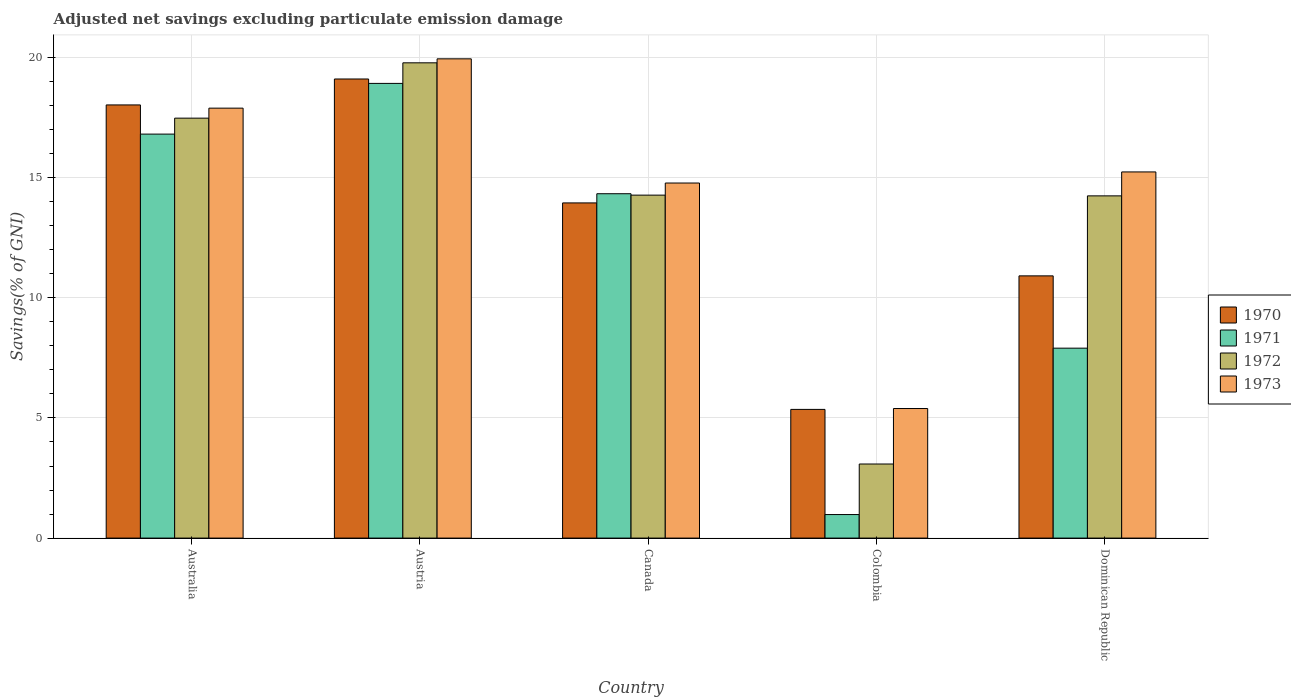Are the number of bars on each tick of the X-axis equal?
Provide a succinct answer. Yes. How many bars are there on the 1st tick from the left?
Make the answer very short. 4. How many bars are there on the 4th tick from the right?
Offer a terse response. 4. What is the label of the 1st group of bars from the left?
Keep it short and to the point. Australia. What is the adjusted net savings in 1973 in Colombia?
Your answer should be very brief. 5.39. Across all countries, what is the maximum adjusted net savings in 1970?
Make the answer very short. 19.11. Across all countries, what is the minimum adjusted net savings in 1970?
Provide a short and direct response. 5.36. In which country was the adjusted net savings in 1972 minimum?
Provide a short and direct response. Colombia. What is the total adjusted net savings in 1973 in the graph?
Give a very brief answer. 73.24. What is the difference between the adjusted net savings in 1973 in Austria and that in Colombia?
Provide a succinct answer. 14.55. What is the difference between the adjusted net savings in 1970 in Dominican Republic and the adjusted net savings in 1971 in Canada?
Ensure brevity in your answer.  -3.42. What is the average adjusted net savings in 1970 per country?
Ensure brevity in your answer.  13.47. What is the difference between the adjusted net savings of/in 1970 and adjusted net savings of/in 1973 in Dominican Republic?
Your answer should be very brief. -4.33. In how many countries, is the adjusted net savings in 1972 greater than 11 %?
Provide a short and direct response. 4. What is the ratio of the adjusted net savings in 1970 in Austria to that in Colombia?
Provide a short and direct response. 3.57. What is the difference between the highest and the second highest adjusted net savings in 1972?
Give a very brief answer. -2.3. What is the difference between the highest and the lowest adjusted net savings in 1972?
Offer a very short reply. 16.7. Is the sum of the adjusted net savings in 1972 in Canada and Colombia greater than the maximum adjusted net savings in 1970 across all countries?
Provide a succinct answer. No. Is it the case that in every country, the sum of the adjusted net savings in 1970 and adjusted net savings in 1973 is greater than the sum of adjusted net savings in 1972 and adjusted net savings in 1971?
Ensure brevity in your answer.  No. How many bars are there?
Provide a succinct answer. 20. How many countries are there in the graph?
Provide a short and direct response. 5. Are the values on the major ticks of Y-axis written in scientific E-notation?
Provide a short and direct response. No. Does the graph contain any zero values?
Give a very brief answer. No. Does the graph contain grids?
Your answer should be compact. Yes. Where does the legend appear in the graph?
Your response must be concise. Center right. What is the title of the graph?
Offer a terse response. Adjusted net savings excluding particulate emission damage. Does "1964" appear as one of the legend labels in the graph?
Keep it short and to the point. No. What is the label or title of the X-axis?
Your answer should be compact. Country. What is the label or title of the Y-axis?
Offer a terse response. Savings(% of GNI). What is the Savings(% of GNI) in 1970 in Australia?
Offer a terse response. 18.03. What is the Savings(% of GNI) in 1971 in Australia?
Make the answer very short. 16.81. What is the Savings(% of GNI) in 1972 in Australia?
Provide a succinct answer. 17.48. What is the Savings(% of GNI) in 1973 in Australia?
Your response must be concise. 17.89. What is the Savings(% of GNI) in 1970 in Austria?
Make the answer very short. 19.11. What is the Savings(% of GNI) of 1971 in Austria?
Keep it short and to the point. 18.92. What is the Savings(% of GNI) in 1972 in Austria?
Ensure brevity in your answer.  19.78. What is the Savings(% of GNI) in 1973 in Austria?
Provide a succinct answer. 19.94. What is the Savings(% of GNI) in 1970 in Canada?
Give a very brief answer. 13.95. What is the Savings(% of GNI) of 1971 in Canada?
Your response must be concise. 14.33. What is the Savings(% of GNI) in 1972 in Canada?
Offer a terse response. 14.27. What is the Savings(% of GNI) in 1973 in Canada?
Offer a terse response. 14.78. What is the Savings(% of GNI) in 1970 in Colombia?
Your response must be concise. 5.36. What is the Savings(% of GNI) of 1971 in Colombia?
Your answer should be very brief. 0.98. What is the Savings(% of GNI) in 1972 in Colombia?
Provide a short and direct response. 3.08. What is the Savings(% of GNI) of 1973 in Colombia?
Keep it short and to the point. 5.39. What is the Savings(% of GNI) in 1970 in Dominican Republic?
Your answer should be very brief. 10.91. What is the Savings(% of GNI) in 1971 in Dominican Republic?
Ensure brevity in your answer.  7.9. What is the Savings(% of GNI) of 1972 in Dominican Republic?
Your answer should be compact. 14.24. What is the Savings(% of GNI) of 1973 in Dominican Republic?
Make the answer very short. 15.24. Across all countries, what is the maximum Savings(% of GNI) in 1970?
Keep it short and to the point. 19.11. Across all countries, what is the maximum Savings(% of GNI) in 1971?
Your response must be concise. 18.92. Across all countries, what is the maximum Savings(% of GNI) in 1972?
Give a very brief answer. 19.78. Across all countries, what is the maximum Savings(% of GNI) in 1973?
Provide a short and direct response. 19.94. Across all countries, what is the minimum Savings(% of GNI) of 1970?
Offer a terse response. 5.36. Across all countries, what is the minimum Savings(% of GNI) in 1971?
Offer a very short reply. 0.98. Across all countries, what is the minimum Savings(% of GNI) in 1972?
Your answer should be compact. 3.08. Across all countries, what is the minimum Savings(% of GNI) in 1973?
Provide a short and direct response. 5.39. What is the total Savings(% of GNI) in 1970 in the graph?
Keep it short and to the point. 67.35. What is the total Savings(% of GNI) of 1971 in the graph?
Give a very brief answer. 58.95. What is the total Savings(% of GNI) of 1972 in the graph?
Give a very brief answer. 68.85. What is the total Savings(% of GNI) in 1973 in the graph?
Your response must be concise. 73.24. What is the difference between the Savings(% of GNI) in 1970 in Australia and that in Austria?
Make the answer very short. -1.08. What is the difference between the Savings(% of GNI) in 1971 in Australia and that in Austria?
Make the answer very short. -2.11. What is the difference between the Savings(% of GNI) in 1972 in Australia and that in Austria?
Ensure brevity in your answer.  -2.3. What is the difference between the Savings(% of GNI) in 1973 in Australia and that in Austria?
Offer a very short reply. -2.05. What is the difference between the Savings(% of GNI) in 1970 in Australia and that in Canada?
Offer a very short reply. 4.08. What is the difference between the Savings(% of GNI) in 1971 in Australia and that in Canada?
Your response must be concise. 2.48. What is the difference between the Savings(% of GNI) of 1972 in Australia and that in Canada?
Give a very brief answer. 3.2. What is the difference between the Savings(% of GNI) of 1973 in Australia and that in Canada?
Offer a terse response. 3.12. What is the difference between the Savings(% of GNI) in 1970 in Australia and that in Colombia?
Your answer should be very brief. 12.67. What is the difference between the Savings(% of GNI) of 1971 in Australia and that in Colombia?
Provide a short and direct response. 15.83. What is the difference between the Savings(% of GNI) of 1972 in Australia and that in Colombia?
Offer a very short reply. 14.39. What is the difference between the Savings(% of GNI) in 1973 in Australia and that in Colombia?
Offer a terse response. 12.5. What is the difference between the Savings(% of GNI) of 1970 in Australia and that in Dominican Republic?
Give a very brief answer. 7.11. What is the difference between the Savings(% of GNI) in 1971 in Australia and that in Dominican Republic?
Keep it short and to the point. 8.91. What is the difference between the Savings(% of GNI) in 1972 in Australia and that in Dominican Republic?
Offer a terse response. 3.23. What is the difference between the Savings(% of GNI) of 1973 in Australia and that in Dominican Republic?
Provide a short and direct response. 2.65. What is the difference between the Savings(% of GNI) of 1970 in Austria and that in Canada?
Ensure brevity in your answer.  5.16. What is the difference between the Savings(% of GNI) of 1971 in Austria and that in Canada?
Make the answer very short. 4.59. What is the difference between the Savings(% of GNI) of 1972 in Austria and that in Canada?
Offer a very short reply. 5.51. What is the difference between the Savings(% of GNI) in 1973 in Austria and that in Canada?
Provide a succinct answer. 5.17. What is the difference between the Savings(% of GNI) in 1970 in Austria and that in Colombia?
Your response must be concise. 13.75. What is the difference between the Savings(% of GNI) in 1971 in Austria and that in Colombia?
Your answer should be very brief. 17.94. What is the difference between the Savings(% of GNI) of 1972 in Austria and that in Colombia?
Your answer should be compact. 16.7. What is the difference between the Savings(% of GNI) in 1973 in Austria and that in Colombia?
Offer a terse response. 14.55. What is the difference between the Savings(% of GNI) in 1970 in Austria and that in Dominican Republic?
Offer a terse response. 8.19. What is the difference between the Savings(% of GNI) of 1971 in Austria and that in Dominican Republic?
Offer a terse response. 11.02. What is the difference between the Savings(% of GNI) in 1972 in Austria and that in Dominican Republic?
Provide a short and direct response. 5.54. What is the difference between the Savings(% of GNI) in 1973 in Austria and that in Dominican Republic?
Offer a very short reply. 4.71. What is the difference between the Savings(% of GNI) in 1970 in Canada and that in Colombia?
Your answer should be very brief. 8.59. What is the difference between the Savings(% of GNI) in 1971 in Canada and that in Colombia?
Make the answer very short. 13.35. What is the difference between the Savings(% of GNI) of 1972 in Canada and that in Colombia?
Make the answer very short. 11.19. What is the difference between the Savings(% of GNI) of 1973 in Canada and that in Colombia?
Ensure brevity in your answer.  9.38. What is the difference between the Savings(% of GNI) of 1970 in Canada and that in Dominican Republic?
Offer a terse response. 3.04. What is the difference between the Savings(% of GNI) in 1971 in Canada and that in Dominican Republic?
Give a very brief answer. 6.43. What is the difference between the Savings(% of GNI) in 1972 in Canada and that in Dominican Republic?
Keep it short and to the point. 0.03. What is the difference between the Savings(% of GNI) of 1973 in Canada and that in Dominican Republic?
Offer a terse response. -0.46. What is the difference between the Savings(% of GNI) in 1970 in Colombia and that in Dominican Republic?
Make the answer very short. -5.56. What is the difference between the Savings(% of GNI) of 1971 in Colombia and that in Dominican Republic?
Your answer should be very brief. -6.92. What is the difference between the Savings(% of GNI) of 1972 in Colombia and that in Dominican Republic?
Your response must be concise. -11.16. What is the difference between the Savings(% of GNI) in 1973 in Colombia and that in Dominican Republic?
Offer a terse response. -9.85. What is the difference between the Savings(% of GNI) of 1970 in Australia and the Savings(% of GNI) of 1971 in Austria?
Make the answer very short. -0.9. What is the difference between the Savings(% of GNI) in 1970 in Australia and the Savings(% of GNI) in 1972 in Austria?
Your answer should be compact. -1.75. What is the difference between the Savings(% of GNI) in 1970 in Australia and the Savings(% of GNI) in 1973 in Austria?
Your answer should be compact. -1.92. What is the difference between the Savings(% of GNI) in 1971 in Australia and the Savings(% of GNI) in 1972 in Austria?
Provide a short and direct response. -2.97. What is the difference between the Savings(% of GNI) of 1971 in Australia and the Savings(% of GNI) of 1973 in Austria?
Make the answer very short. -3.13. What is the difference between the Savings(% of GNI) of 1972 in Australia and the Savings(% of GNI) of 1973 in Austria?
Offer a very short reply. -2.47. What is the difference between the Savings(% of GNI) of 1970 in Australia and the Savings(% of GNI) of 1971 in Canada?
Your response must be concise. 3.7. What is the difference between the Savings(% of GNI) in 1970 in Australia and the Savings(% of GNI) in 1972 in Canada?
Provide a succinct answer. 3.75. What is the difference between the Savings(% of GNI) in 1970 in Australia and the Savings(% of GNI) in 1973 in Canada?
Keep it short and to the point. 3.25. What is the difference between the Savings(% of GNI) of 1971 in Australia and the Savings(% of GNI) of 1972 in Canada?
Your response must be concise. 2.54. What is the difference between the Savings(% of GNI) of 1971 in Australia and the Savings(% of GNI) of 1973 in Canada?
Provide a succinct answer. 2.04. What is the difference between the Savings(% of GNI) in 1972 in Australia and the Savings(% of GNI) in 1973 in Canada?
Provide a short and direct response. 2.7. What is the difference between the Savings(% of GNI) of 1970 in Australia and the Savings(% of GNI) of 1971 in Colombia?
Your answer should be very brief. 17.05. What is the difference between the Savings(% of GNI) in 1970 in Australia and the Savings(% of GNI) in 1972 in Colombia?
Offer a very short reply. 14.94. What is the difference between the Savings(% of GNI) in 1970 in Australia and the Savings(% of GNI) in 1973 in Colombia?
Provide a short and direct response. 12.63. What is the difference between the Savings(% of GNI) in 1971 in Australia and the Savings(% of GNI) in 1972 in Colombia?
Your answer should be compact. 13.73. What is the difference between the Savings(% of GNI) of 1971 in Australia and the Savings(% of GNI) of 1973 in Colombia?
Offer a terse response. 11.42. What is the difference between the Savings(% of GNI) in 1972 in Australia and the Savings(% of GNI) in 1973 in Colombia?
Your answer should be compact. 12.08. What is the difference between the Savings(% of GNI) in 1970 in Australia and the Savings(% of GNI) in 1971 in Dominican Republic?
Give a very brief answer. 10.12. What is the difference between the Savings(% of GNI) in 1970 in Australia and the Savings(% of GNI) in 1972 in Dominican Republic?
Your answer should be very brief. 3.78. What is the difference between the Savings(% of GNI) of 1970 in Australia and the Savings(% of GNI) of 1973 in Dominican Republic?
Offer a very short reply. 2.79. What is the difference between the Savings(% of GNI) in 1971 in Australia and the Savings(% of GNI) in 1972 in Dominican Republic?
Your answer should be compact. 2.57. What is the difference between the Savings(% of GNI) in 1971 in Australia and the Savings(% of GNI) in 1973 in Dominican Republic?
Give a very brief answer. 1.57. What is the difference between the Savings(% of GNI) in 1972 in Australia and the Savings(% of GNI) in 1973 in Dominican Republic?
Make the answer very short. 2.24. What is the difference between the Savings(% of GNI) in 1970 in Austria and the Savings(% of GNI) in 1971 in Canada?
Make the answer very short. 4.77. What is the difference between the Savings(% of GNI) in 1970 in Austria and the Savings(% of GNI) in 1972 in Canada?
Ensure brevity in your answer.  4.83. What is the difference between the Savings(% of GNI) in 1970 in Austria and the Savings(% of GNI) in 1973 in Canada?
Ensure brevity in your answer.  4.33. What is the difference between the Savings(% of GNI) of 1971 in Austria and the Savings(% of GNI) of 1972 in Canada?
Your response must be concise. 4.65. What is the difference between the Savings(% of GNI) in 1971 in Austria and the Savings(% of GNI) in 1973 in Canada?
Offer a very short reply. 4.15. What is the difference between the Savings(% of GNI) in 1972 in Austria and the Savings(% of GNI) in 1973 in Canada?
Ensure brevity in your answer.  5. What is the difference between the Savings(% of GNI) of 1970 in Austria and the Savings(% of GNI) of 1971 in Colombia?
Give a very brief answer. 18.13. What is the difference between the Savings(% of GNI) in 1970 in Austria and the Savings(% of GNI) in 1972 in Colombia?
Ensure brevity in your answer.  16.02. What is the difference between the Savings(% of GNI) of 1970 in Austria and the Savings(% of GNI) of 1973 in Colombia?
Keep it short and to the point. 13.71. What is the difference between the Savings(% of GNI) of 1971 in Austria and the Savings(% of GNI) of 1972 in Colombia?
Offer a terse response. 15.84. What is the difference between the Savings(% of GNI) in 1971 in Austria and the Savings(% of GNI) in 1973 in Colombia?
Make the answer very short. 13.53. What is the difference between the Savings(% of GNI) in 1972 in Austria and the Savings(% of GNI) in 1973 in Colombia?
Provide a succinct answer. 14.39. What is the difference between the Savings(% of GNI) in 1970 in Austria and the Savings(% of GNI) in 1971 in Dominican Republic?
Offer a very short reply. 11.2. What is the difference between the Savings(% of GNI) in 1970 in Austria and the Savings(% of GNI) in 1972 in Dominican Republic?
Your response must be concise. 4.86. What is the difference between the Savings(% of GNI) of 1970 in Austria and the Savings(% of GNI) of 1973 in Dominican Republic?
Keep it short and to the point. 3.87. What is the difference between the Savings(% of GNI) in 1971 in Austria and the Savings(% of GNI) in 1972 in Dominican Republic?
Your response must be concise. 4.68. What is the difference between the Savings(% of GNI) of 1971 in Austria and the Savings(% of GNI) of 1973 in Dominican Republic?
Keep it short and to the point. 3.68. What is the difference between the Savings(% of GNI) in 1972 in Austria and the Savings(% of GNI) in 1973 in Dominican Republic?
Provide a succinct answer. 4.54. What is the difference between the Savings(% of GNI) of 1970 in Canada and the Savings(% of GNI) of 1971 in Colombia?
Provide a succinct answer. 12.97. What is the difference between the Savings(% of GNI) of 1970 in Canada and the Savings(% of GNI) of 1972 in Colombia?
Provide a succinct answer. 10.87. What is the difference between the Savings(% of GNI) of 1970 in Canada and the Savings(% of GNI) of 1973 in Colombia?
Provide a succinct answer. 8.56. What is the difference between the Savings(% of GNI) of 1971 in Canada and the Savings(% of GNI) of 1972 in Colombia?
Ensure brevity in your answer.  11.25. What is the difference between the Savings(% of GNI) in 1971 in Canada and the Savings(% of GNI) in 1973 in Colombia?
Provide a short and direct response. 8.94. What is the difference between the Savings(% of GNI) in 1972 in Canada and the Savings(% of GNI) in 1973 in Colombia?
Make the answer very short. 8.88. What is the difference between the Savings(% of GNI) in 1970 in Canada and the Savings(% of GNI) in 1971 in Dominican Republic?
Keep it short and to the point. 6.05. What is the difference between the Savings(% of GNI) of 1970 in Canada and the Savings(% of GNI) of 1972 in Dominican Republic?
Ensure brevity in your answer.  -0.29. What is the difference between the Savings(% of GNI) in 1970 in Canada and the Savings(% of GNI) in 1973 in Dominican Republic?
Your response must be concise. -1.29. What is the difference between the Savings(% of GNI) in 1971 in Canada and the Savings(% of GNI) in 1972 in Dominican Republic?
Offer a very short reply. 0.09. What is the difference between the Savings(% of GNI) in 1971 in Canada and the Savings(% of GNI) in 1973 in Dominican Republic?
Provide a short and direct response. -0.91. What is the difference between the Savings(% of GNI) in 1972 in Canada and the Savings(% of GNI) in 1973 in Dominican Republic?
Offer a very short reply. -0.97. What is the difference between the Savings(% of GNI) in 1970 in Colombia and the Savings(% of GNI) in 1971 in Dominican Republic?
Ensure brevity in your answer.  -2.55. What is the difference between the Savings(% of GNI) in 1970 in Colombia and the Savings(% of GNI) in 1972 in Dominican Republic?
Keep it short and to the point. -8.89. What is the difference between the Savings(% of GNI) of 1970 in Colombia and the Savings(% of GNI) of 1973 in Dominican Republic?
Provide a succinct answer. -9.88. What is the difference between the Savings(% of GNI) in 1971 in Colombia and the Savings(% of GNI) in 1972 in Dominican Republic?
Offer a terse response. -13.26. What is the difference between the Savings(% of GNI) of 1971 in Colombia and the Savings(% of GNI) of 1973 in Dominican Republic?
Ensure brevity in your answer.  -14.26. What is the difference between the Savings(% of GNI) of 1972 in Colombia and the Savings(% of GNI) of 1973 in Dominican Republic?
Provide a succinct answer. -12.15. What is the average Savings(% of GNI) in 1970 per country?
Keep it short and to the point. 13.47. What is the average Savings(% of GNI) in 1971 per country?
Provide a short and direct response. 11.79. What is the average Savings(% of GNI) in 1972 per country?
Your answer should be compact. 13.77. What is the average Savings(% of GNI) in 1973 per country?
Your answer should be compact. 14.65. What is the difference between the Savings(% of GNI) of 1970 and Savings(% of GNI) of 1971 in Australia?
Your response must be concise. 1.21. What is the difference between the Savings(% of GNI) in 1970 and Savings(% of GNI) in 1972 in Australia?
Provide a succinct answer. 0.55. What is the difference between the Savings(% of GNI) of 1970 and Savings(% of GNI) of 1973 in Australia?
Offer a very short reply. 0.13. What is the difference between the Savings(% of GNI) in 1971 and Savings(% of GNI) in 1972 in Australia?
Offer a very short reply. -0.66. What is the difference between the Savings(% of GNI) of 1971 and Savings(% of GNI) of 1973 in Australia?
Keep it short and to the point. -1.08. What is the difference between the Savings(% of GNI) of 1972 and Savings(% of GNI) of 1973 in Australia?
Offer a very short reply. -0.42. What is the difference between the Savings(% of GNI) of 1970 and Savings(% of GNI) of 1971 in Austria?
Keep it short and to the point. 0.18. What is the difference between the Savings(% of GNI) in 1970 and Savings(% of GNI) in 1972 in Austria?
Your answer should be very brief. -0.67. What is the difference between the Savings(% of GNI) of 1970 and Savings(% of GNI) of 1973 in Austria?
Give a very brief answer. -0.84. What is the difference between the Savings(% of GNI) in 1971 and Savings(% of GNI) in 1972 in Austria?
Make the answer very short. -0.86. What is the difference between the Savings(% of GNI) of 1971 and Savings(% of GNI) of 1973 in Austria?
Ensure brevity in your answer.  -1.02. What is the difference between the Savings(% of GNI) of 1972 and Savings(% of GNI) of 1973 in Austria?
Make the answer very short. -0.17. What is the difference between the Savings(% of GNI) of 1970 and Savings(% of GNI) of 1971 in Canada?
Your answer should be very brief. -0.38. What is the difference between the Savings(% of GNI) in 1970 and Savings(% of GNI) in 1972 in Canada?
Your answer should be compact. -0.32. What is the difference between the Savings(% of GNI) of 1970 and Savings(% of GNI) of 1973 in Canada?
Your answer should be very brief. -0.83. What is the difference between the Savings(% of GNI) in 1971 and Savings(% of GNI) in 1972 in Canada?
Provide a succinct answer. 0.06. What is the difference between the Savings(% of GNI) in 1971 and Savings(% of GNI) in 1973 in Canada?
Give a very brief answer. -0.45. What is the difference between the Savings(% of GNI) in 1972 and Savings(% of GNI) in 1973 in Canada?
Keep it short and to the point. -0.5. What is the difference between the Savings(% of GNI) of 1970 and Savings(% of GNI) of 1971 in Colombia?
Make the answer very short. 4.38. What is the difference between the Savings(% of GNI) of 1970 and Savings(% of GNI) of 1972 in Colombia?
Make the answer very short. 2.27. What is the difference between the Savings(% of GNI) in 1970 and Savings(% of GNI) in 1973 in Colombia?
Provide a short and direct response. -0.04. What is the difference between the Savings(% of GNI) in 1971 and Savings(% of GNI) in 1972 in Colombia?
Give a very brief answer. -2.1. What is the difference between the Savings(% of GNI) in 1971 and Savings(% of GNI) in 1973 in Colombia?
Make the answer very short. -4.41. What is the difference between the Savings(% of GNI) of 1972 and Savings(% of GNI) of 1973 in Colombia?
Keep it short and to the point. -2.31. What is the difference between the Savings(% of GNI) of 1970 and Savings(% of GNI) of 1971 in Dominican Republic?
Make the answer very short. 3.01. What is the difference between the Savings(% of GNI) in 1970 and Savings(% of GNI) in 1972 in Dominican Republic?
Offer a very short reply. -3.33. What is the difference between the Savings(% of GNI) of 1970 and Savings(% of GNI) of 1973 in Dominican Republic?
Make the answer very short. -4.33. What is the difference between the Savings(% of GNI) of 1971 and Savings(% of GNI) of 1972 in Dominican Republic?
Your answer should be compact. -6.34. What is the difference between the Savings(% of GNI) of 1971 and Savings(% of GNI) of 1973 in Dominican Republic?
Ensure brevity in your answer.  -7.33. What is the difference between the Savings(% of GNI) in 1972 and Savings(% of GNI) in 1973 in Dominican Republic?
Offer a terse response. -1. What is the ratio of the Savings(% of GNI) of 1970 in Australia to that in Austria?
Offer a very short reply. 0.94. What is the ratio of the Savings(% of GNI) of 1971 in Australia to that in Austria?
Keep it short and to the point. 0.89. What is the ratio of the Savings(% of GNI) in 1972 in Australia to that in Austria?
Make the answer very short. 0.88. What is the ratio of the Savings(% of GNI) of 1973 in Australia to that in Austria?
Offer a very short reply. 0.9. What is the ratio of the Savings(% of GNI) of 1970 in Australia to that in Canada?
Provide a succinct answer. 1.29. What is the ratio of the Savings(% of GNI) of 1971 in Australia to that in Canada?
Your answer should be compact. 1.17. What is the ratio of the Savings(% of GNI) in 1972 in Australia to that in Canada?
Provide a succinct answer. 1.22. What is the ratio of the Savings(% of GNI) in 1973 in Australia to that in Canada?
Your response must be concise. 1.21. What is the ratio of the Savings(% of GNI) of 1970 in Australia to that in Colombia?
Provide a succinct answer. 3.37. What is the ratio of the Savings(% of GNI) in 1971 in Australia to that in Colombia?
Give a very brief answer. 17.17. What is the ratio of the Savings(% of GNI) of 1972 in Australia to that in Colombia?
Ensure brevity in your answer.  5.67. What is the ratio of the Savings(% of GNI) in 1973 in Australia to that in Colombia?
Give a very brief answer. 3.32. What is the ratio of the Savings(% of GNI) in 1970 in Australia to that in Dominican Republic?
Offer a terse response. 1.65. What is the ratio of the Savings(% of GNI) of 1971 in Australia to that in Dominican Republic?
Keep it short and to the point. 2.13. What is the ratio of the Savings(% of GNI) of 1972 in Australia to that in Dominican Republic?
Provide a succinct answer. 1.23. What is the ratio of the Savings(% of GNI) of 1973 in Australia to that in Dominican Republic?
Offer a terse response. 1.17. What is the ratio of the Savings(% of GNI) of 1970 in Austria to that in Canada?
Your answer should be compact. 1.37. What is the ratio of the Savings(% of GNI) in 1971 in Austria to that in Canada?
Provide a succinct answer. 1.32. What is the ratio of the Savings(% of GNI) in 1972 in Austria to that in Canada?
Keep it short and to the point. 1.39. What is the ratio of the Savings(% of GNI) in 1973 in Austria to that in Canada?
Offer a very short reply. 1.35. What is the ratio of the Savings(% of GNI) in 1970 in Austria to that in Colombia?
Provide a succinct answer. 3.57. What is the ratio of the Savings(% of GNI) in 1971 in Austria to that in Colombia?
Offer a terse response. 19.32. What is the ratio of the Savings(% of GNI) in 1972 in Austria to that in Colombia?
Your response must be concise. 6.42. What is the ratio of the Savings(% of GNI) in 1973 in Austria to that in Colombia?
Make the answer very short. 3.7. What is the ratio of the Savings(% of GNI) in 1970 in Austria to that in Dominican Republic?
Make the answer very short. 1.75. What is the ratio of the Savings(% of GNI) of 1971 in Austria to that in Dominican Republic?
Ensure brevity in your answer.  2.39. What is the ratio of the Savings(% of GNI) of 1972 in Austria to that in Dominican Republic?
Your response must be concise. 1.39. What is the ratio of the Savings(% of GNI) in 1973 in Austria to that in Dominican Republic?
Provide a short and direct response. 1.31. What is the ratio of the Savings(% of GNI) in 1970 in Canada to that in Colombia?
Provide a succinct answer. 2.6. What is the ratio of the Savings(% of GNI) of 1971 in Canada to that in Colombia?
Your answer should be very brief. 14.64. What is the ratio of the Savings(% of GNI) in 1972 in Canada to that in Colombia?
Your answer should be very brief. 4.63. What is the ratio of the Savings(% of GNI) in 1973 in Canada to that in Colombia?
Keep it short and to the point. 2.74. What is the ratio of the Savings(% of GNI) of 1970 in Canada to that in Dominican Republic?
Provide a short and direct response. 1.28. What is the ratio of the Savings(% of GNI) in 1971 in Canada to that in Dominican Republic?
Your response must be concise. 1.81. What is the ratio of the Savings(% of GNI) of 1973 in Canada to that in Dominican Republic?
Your answer should be very brief. 0.97. What is the ratio of the Savings(% of GNI) of 1970 in Colombia to that in Dominican Republic?
Provide a short and direct response. 0.49. What is the ratio of the Savings(% of GNI) of 1971 in Colombia to that in Dominican Republic?
Ensure brevity in your answer.  0.12. What is the ratio of the Savings(% of GNI) in 1972 in Colombia to that in Dominican Republic?
Offer a terse response. 0.22. What is the ratio of the Savings(% of GNI) in 1973 in Colombia to that in Dominican Republic?
Provide a short and direct response. 0.35. What is the difference between the highest and the second highest Savings(% of GNI) in 1970?
Your answer should be compact. 1.08. What is the difference between the highest and the second highest Savings(% of GNI) in 1971?
Keep it short and to the point. 2.11. What is the difference between the highest and the second highest Savings(% of GNI) in 1972?
Give a very brief answer. 2.3. What is the difference between the highest and the second highest Savings(% of GNI) of 1973?
Your answer should be very brief. 2.05. What is the difference between the highest and the lowest Savings(% of GNI) of 1970?
Provide a short and direct response. 13.75. What is the difference between the highest and the lowest Savings(% of GNI) of 1971?
Make the answer very short. 17.94. What is the difference between the highest and the lowest Savings(% of GNI) of 1972?
Make the answer very short. 16.7. What is the difference between the highest and the lowest Savings(% of GNI) in 1973?
Provide a short and direct response. 14.55. 